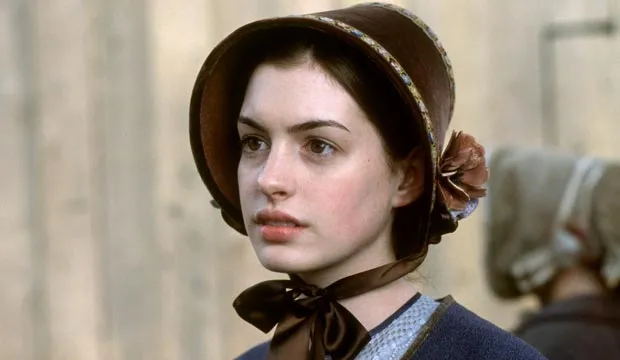What do you think is happening in the scene just before and after this moment? Just before this moment, the character might have been engaged in a conversation or an event of great emotional significance, perhaps receiving news or making a decision. After this snapshot, she might be moving towards taking action based on the thoughts that are occupying her mind. The blurred figure in the background suggests that someone might have been interacting with her, adding to the tension or gravity of the situation. Imagine this character's inner monologue. What might she be thinking? "Is this truly the right path for me? The weight of my choices seems overwhelming, and yet, I must remain strong. Every gaze, every whisper from society presses upon my shoulders. Must I sacrifice my own desires for the good of my family? Or is there a way to balance duty with personal happiness? The world around me is changing, and I feel so small amidst it all. How do I navigate this labyrinth of expectations?" Think of a very creative scenario involving this character. What could it be? In a twist of imagination, let's place this character in an alternate universe where time travel is possible. She's a secret agent from the Regency era sent to the future to gather information about technological advancements. Every day, she toggles between her historical life filled with social decorum and a futuristic, bustling city where she must blend in and gather knowledge about inventions that could change her past. Her bonnet and dress are modified with hidden gadgets, allowing her to record data and transport it back to her time. Navigating the complexities of both worlds, she must keep her double life a secret and ensure history unfolds seamlessly. 